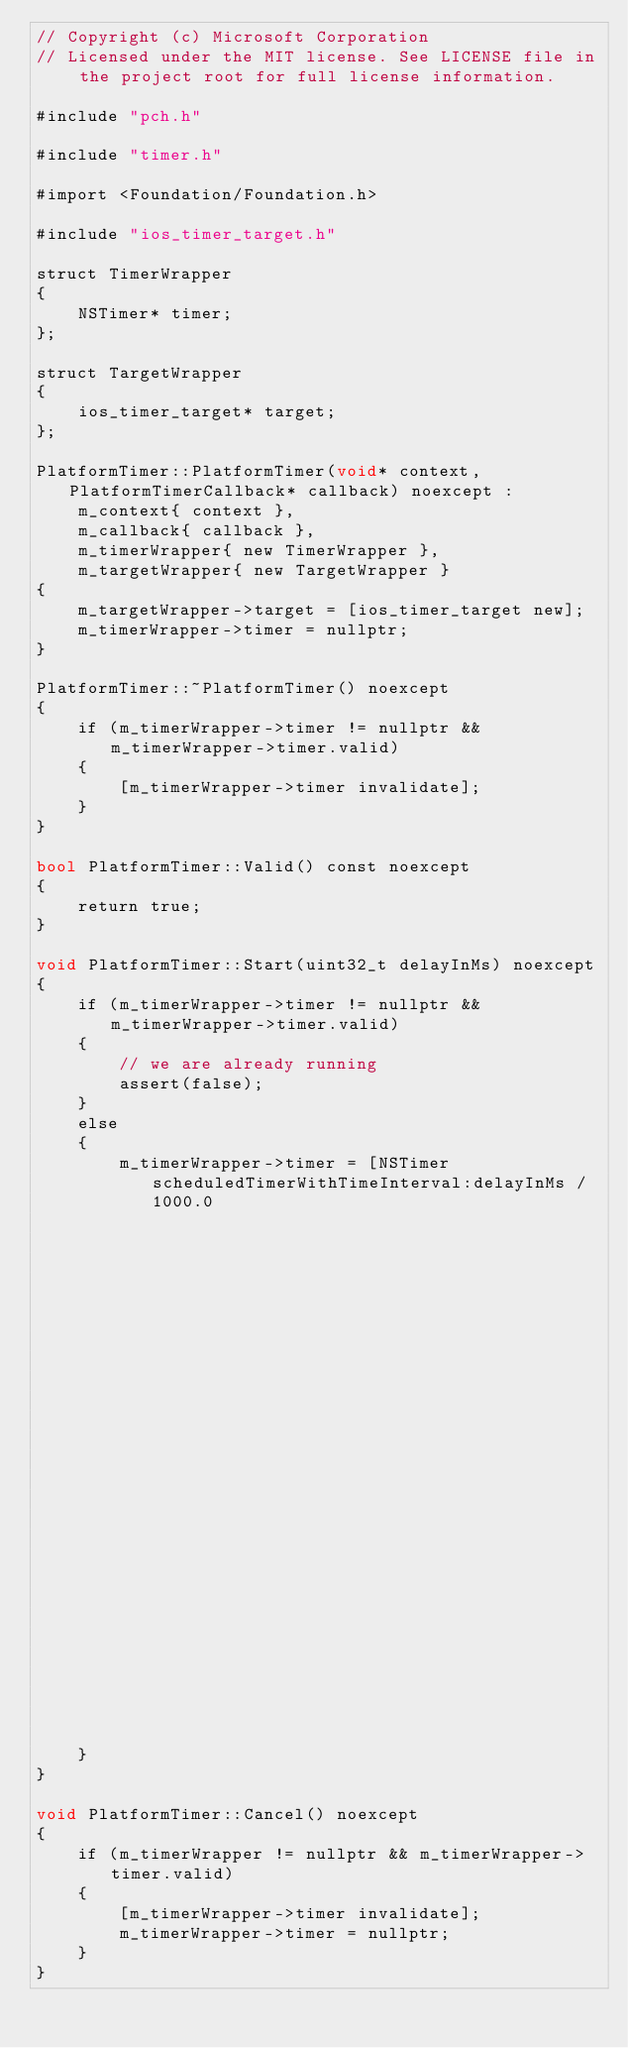<code> <loc_0><loc_0><loc_500><loc_500><_ObjectiveC_>// Copyright (c) Microsoft Corporation
// Licensed under the MIT license. See LICENSE file in the project root for full license information.

#include "pch.h"

#include "timer.h"

#import <Foundation/Foundation.h>

#include "ios_timer_target.h"

struct TimerWrapper
{
    NSTimer* timer;
};

struct TargetWrapper
{
    ios_timer_target* target;
};

PlatformTimer::PlatformTimer(void* context, PlatformTimerCallback* callback) noexcept :
    m_context{ context },
    m_callback{ callback },
    m_timerWrapper{ new TimerWrapper },
    m_targetWrapper{ new TargetWrapper }
{
    m_targetWrapper->target = [ios_timer_target new];
    m_timerWrapper->timer = nullptr;
}

PlatformTimer::~PlatformTimer() noexcept
{
    if (m_timerWrapper->timer != nullptr && m_timerWrapper->timer.valid)
    {
        [m_timerWrapper->timer invalidate];
    }
}

bool PlatformTimer::Valid() const noexcept
{
    return true;
}

void PlatformTimer::Start(uint32_t delayInMs) noexcept
{
    if (m_timerWrapper->timer != nullptr && m_timerWrapper->timer.valid)
    {
        // we are already running
        assert(false);
    }
    else
    {
        m_timerWrapper->timer = [NSTimer scheduledTimerWithTimeInterval:delayInMs / 1000.0
                                                                 target:m_targetWrapper->target
                                                               selector:@selector(timerFireMethod:)
                                                               userInfo:[NSValue valueWithPointer:this]
                                                                repeats:false];
    }
}

void PlatformTimer::Cancel() noexcept
{
    if (m_timerWrapper != nullptr && m_timerWrapper->timer.valid)
    {
        [m_timerWrapper->timer invalidate];
        m_timerWrapper->timer = nullptr;
    }
}
</code> 